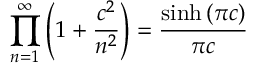<formula> <loc_0><loc_0><loc_500><loc_500>\prod _ { n = 1 } ^ { \infty } \left ( 1 + \frac { c ^ { 2 } } { n ^ { 2 } } \right ) = \frac { \sinh \left ( \pi c \right ) } { \pi c }</formula> 